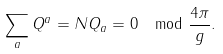Convert formula to latex. <formula><loc_0><loc_0><loc_500><loc_500>\sum _ { a } Q ^ { a } = N Q _ { a } = 0 \mod \frac { 4 \pi } { g } .</formula> 